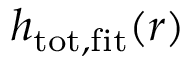<formula> <loc_0><loc_0><loc_500><loc_500>h _ { t o t , f i t } ( r )</formula> 